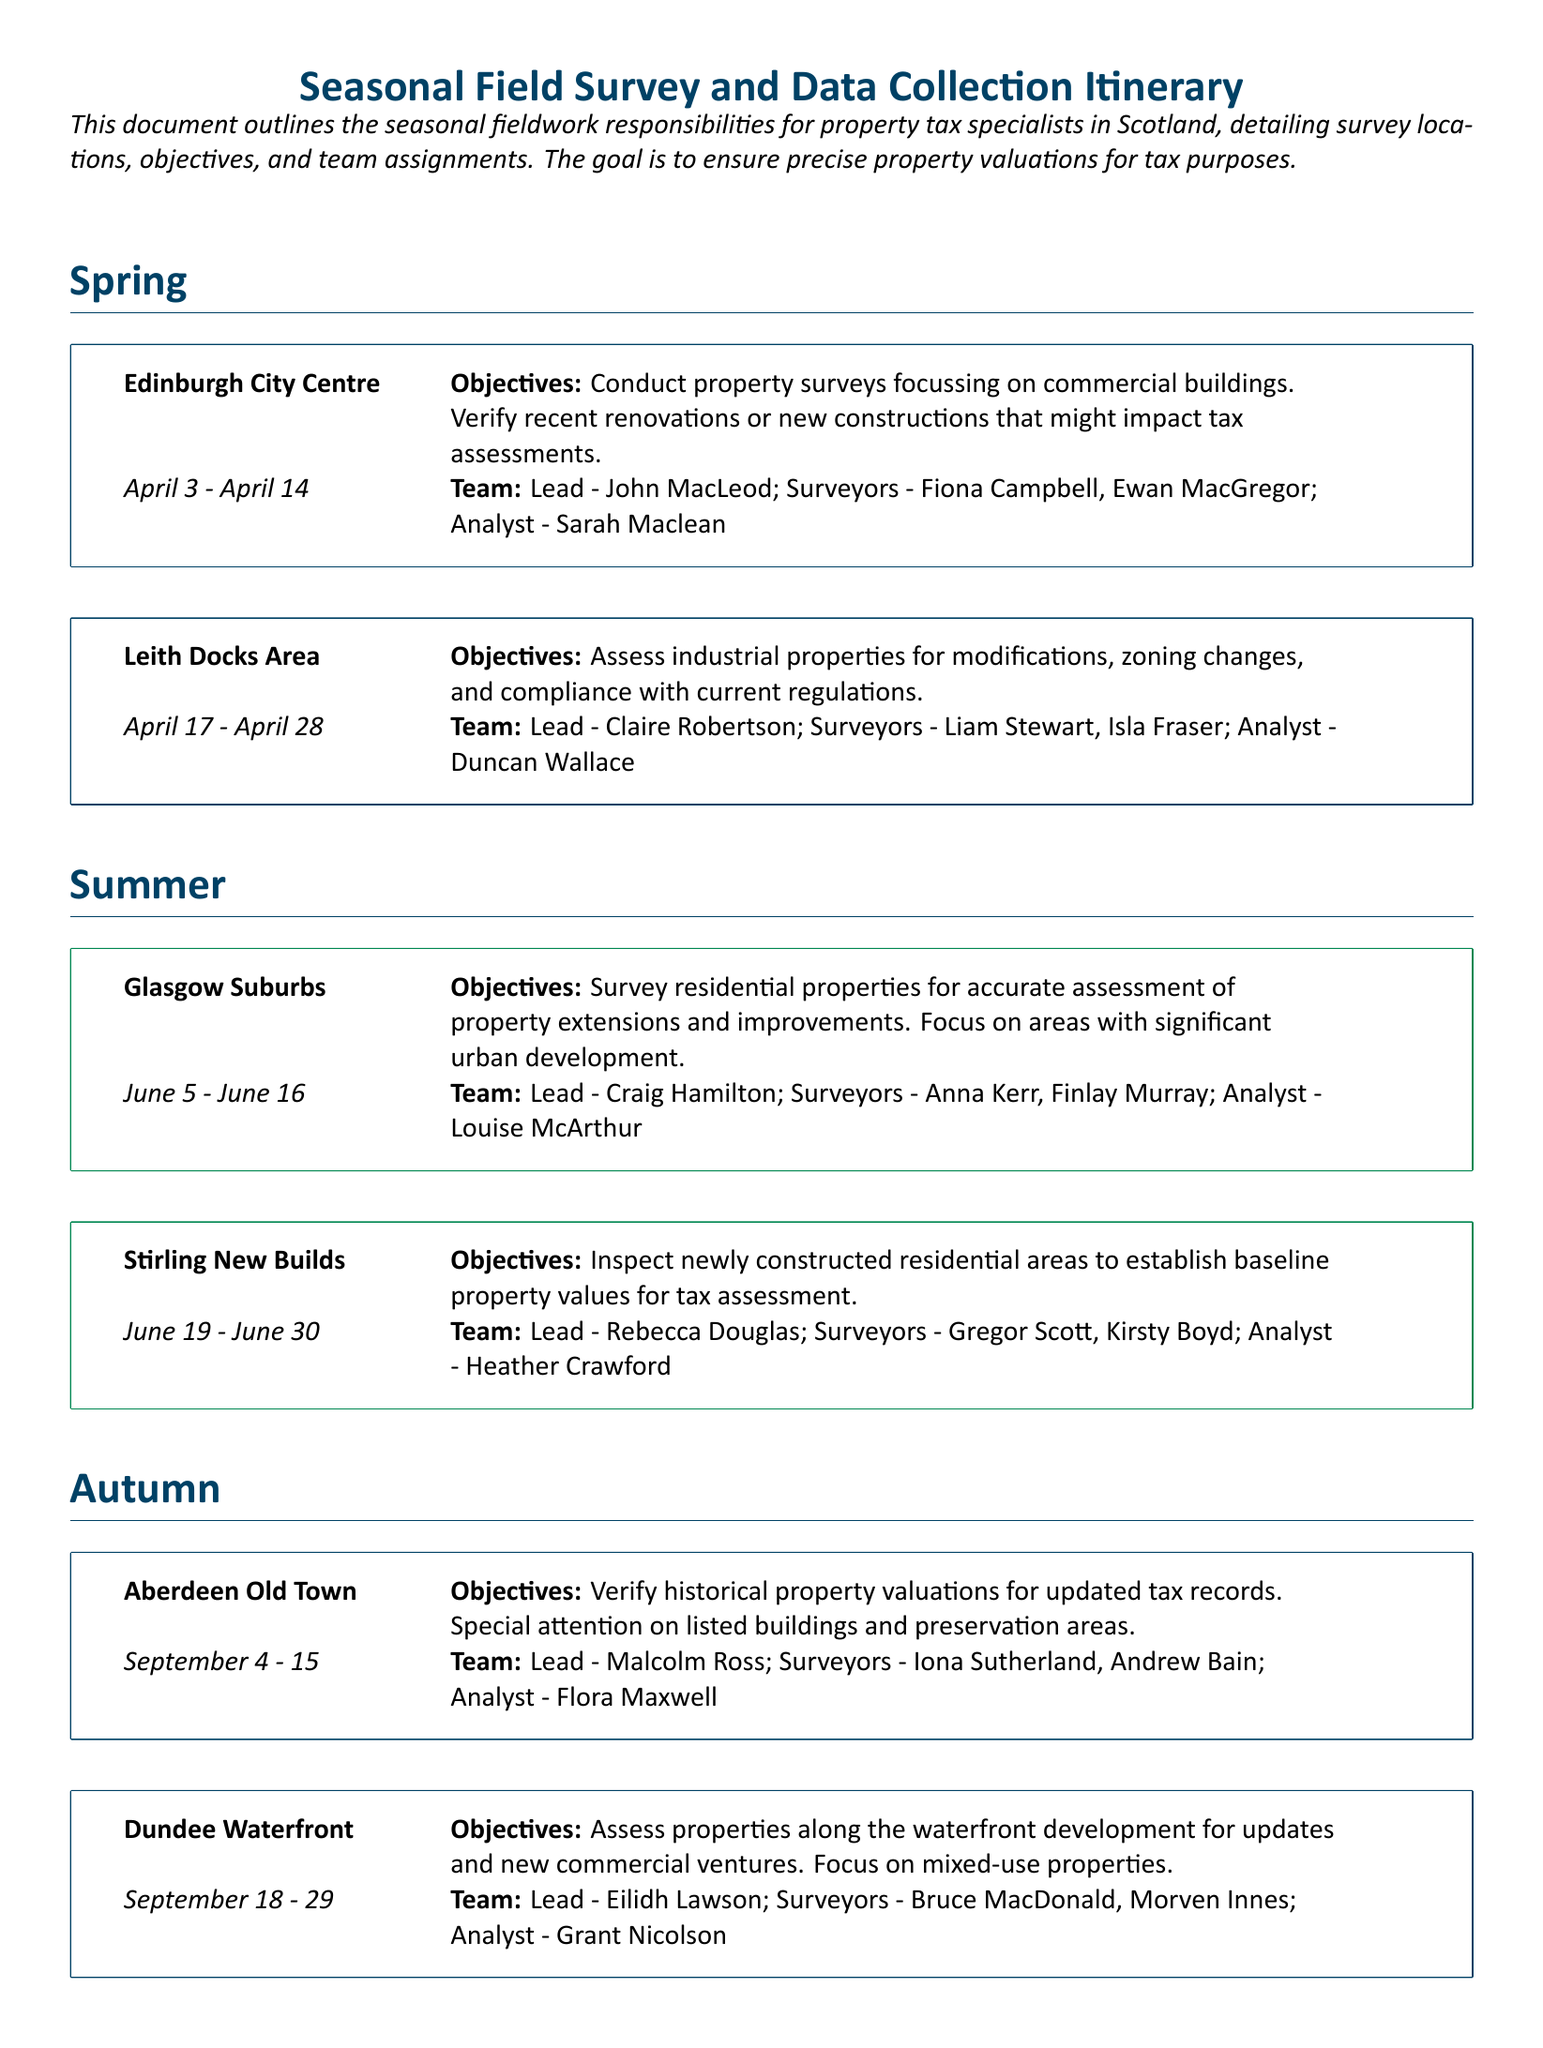What are the survey dates for Edinburgh City Centre? The survey dates for Edinburgh City Centre are April 3 to April 14.
Answer: April 3 - April 14 Who is the lead for the Leith Docks Area survey? The lead for the Leith Docks Area survey is Claire Robertson.
Answer: Claire Robertson What is the objective of the Glasgow Suburbs survey? The objective of the Glasgow Suburbs survey is to survey residential properties for accurate assessment of property extensions and improvements.
Answer: Survey residential properties for accurate assessment of property extensions and improvements How many team members are assigned to the Dundee Waterfront survey? The Dundee Waterfront survey team has four members: lead, two surveyors, and one analyst.
Answer: Four What is the focus of the Inverness Rural Areas survey? The focus of the Inverness Rural Areas survey is to conduct surveys of rural and agricultural properties.
Answer: Rural and agricultural properties What season does the Stirling New Builds survey fall under? The Stirling New Builds survey falls under the summer season.
Answer: Summer What is the main focus of the Autumn surveys in this itinerary? The main focus of the Autumn surveys is verifying historical property valuations for updated tax records.
Answer: Verifying historical property valuations Which area is inspected during the Winter season? The area inspected during the Winter season is Inverness Rural Areas.
Answer: Inverness Rural Areas 